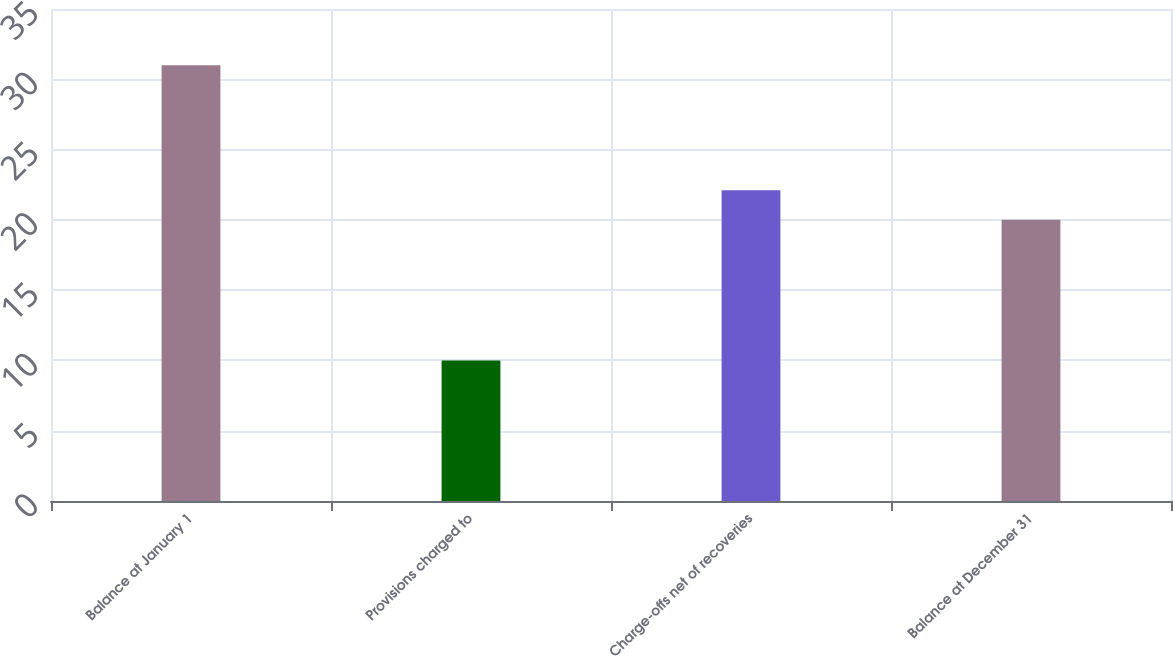Convert chart to OTSL. <chart><loc_0><loc_0><loc_500><loc_500><bar_chart><fcel>Balance at January 1<fcel>Provisions charged to<fcel>Charge-offs net of recoveries<fcel>Balance at December 31<nl><fcel>31<fcel>10<fcel>22.1<fcel>20<nl></chart> 